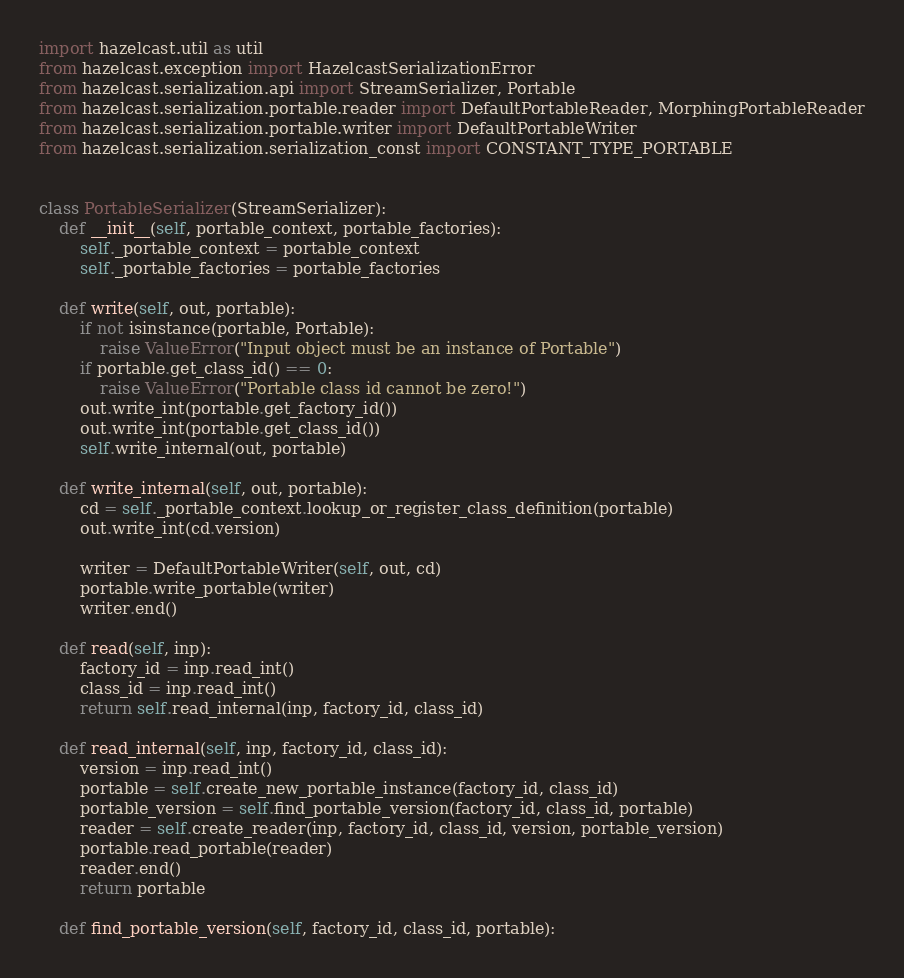<code> <loc_0><loc_0><loc_500><loc_500><_Python_>import hazelcast.util as util
from hazelcast.exception import HazelcastSerializationError
from hazelcast.serialization.api import StreamSerializer, Portable
from hazelcast.serialization.portable.reader import DefaultPortableReader, MorphingPortableReader
from hazelcast.serialization.portable.writer import DefaultPortableWriter
from hazelcast.serialization.serialization_const import CONSTANT_TYPE_PORTABLE


class PortableSerializer(StreamSerializer):
    def __init__(self, portable_context, portable_factories):
        self._portable_context = portable_context
        self._portable_factories = portable_factories

    def write(self, out, portable):
        if not isinstance(portable, Portable):
            raise ValueError("Input object must be an instance of Portable")
        if portable.get_class_id() == 0:
            raise ValueError("Portable class id cannot be zero!")
        out.write_int(portable.get_factory_id())
        out.write_int(portable.get_class_id())
        self.write_internal(out, portable)

    def write_internal(self, out, portable):
        cd = self._portable_context.lookup_or_register_class_definition(portable)
        out.write_int(cd.version)

        writer = DefaultPortableWriter(self, out, cd)
        portable.write_portable(writer)
        writer.end()

    def read(self, inp):
        factory_id = inp.read_int()
        class_id = inp.read_int()
        return self.read_internal(inp, factory_id, class_id)

    def read_internal(self, inp, factory_id, class_id):
        version = inp.read_int()
        portable = self.create_new_portable_instance(factory_id, class_id)
        portable_version = self.find_portable_version(factory_id, class_id, portable)
        reader = self.create_reader(inp, factory_id, class_id, version, portable_version)
        portable.read_portable(reader)
        reader.end()
        return portable

    def find_portable_version(self, factory_id, class_id, portable):</code> 